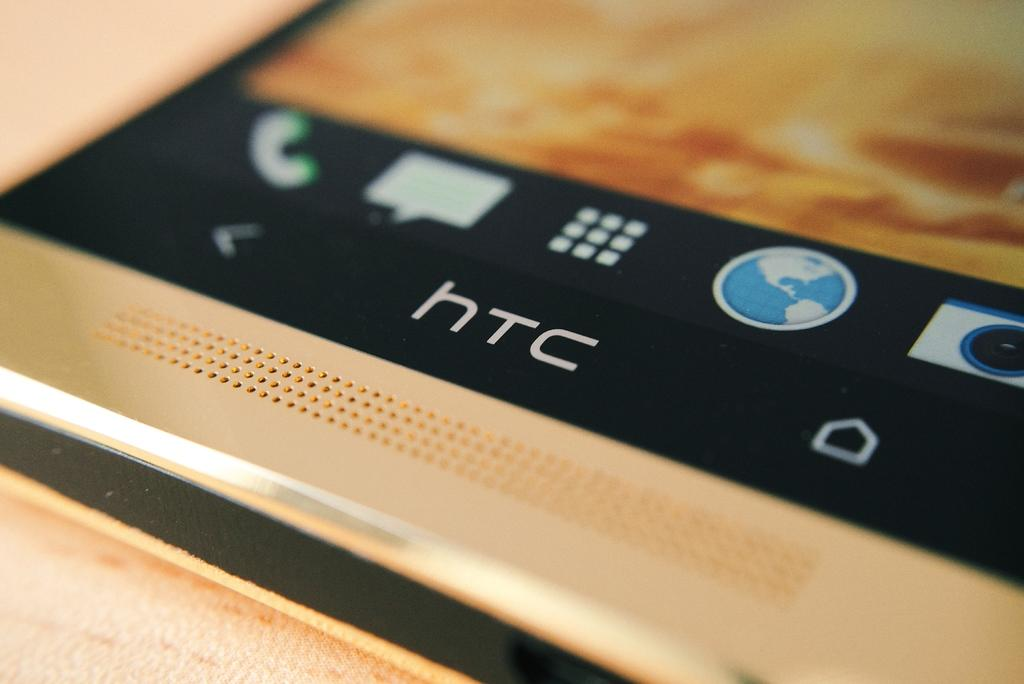<image>
Present a compact description of the photo's key features. An electronic device, manufactured by HTC, is resting on a wooden surface. 